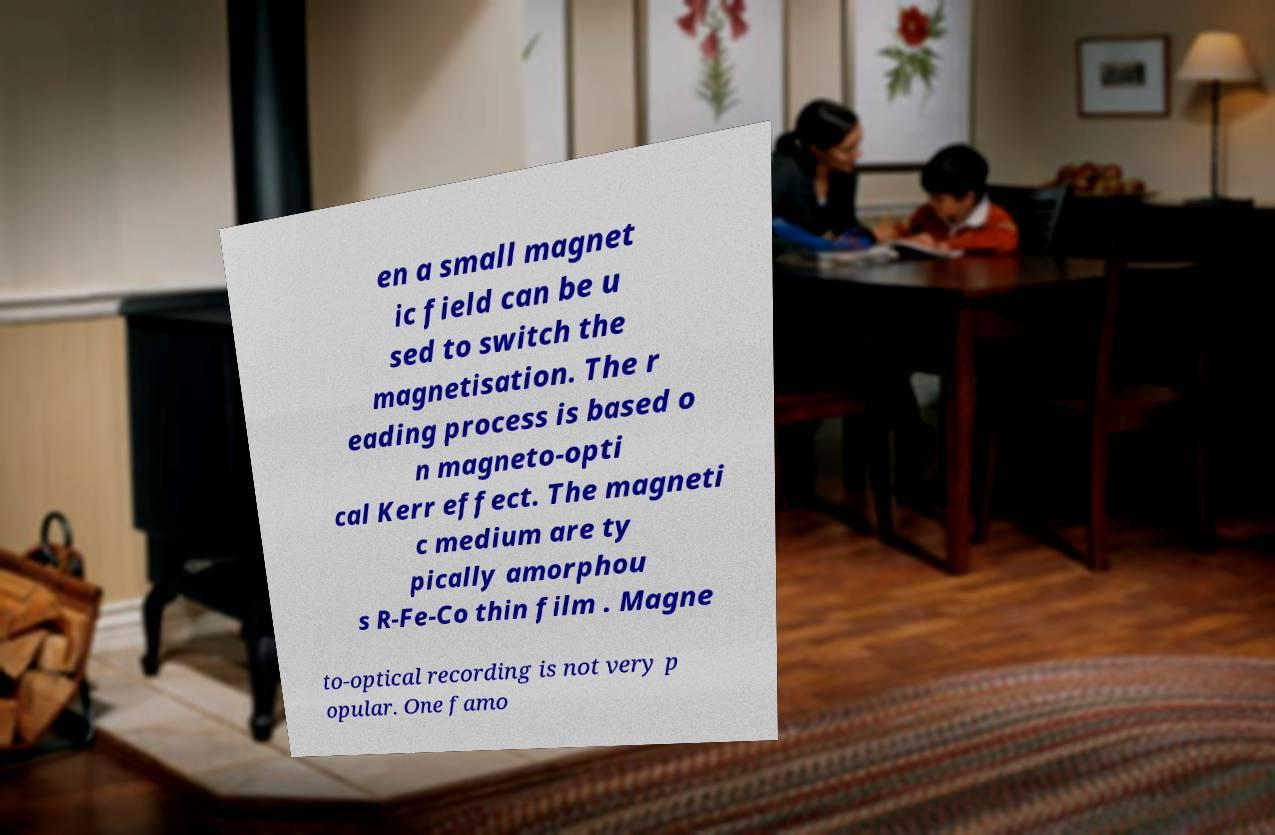Could you assist in decoding the text presented in this image and type it out clearly? en a small magnet ic field can be u sed to switch the magnetisation. The r eading process is based o n magneto-opti cal Kerr effect. The magneti c medium are ty pically amorphou s R-Fe-Co thin film . Magne to-optical recording is not very p opular. One famo 